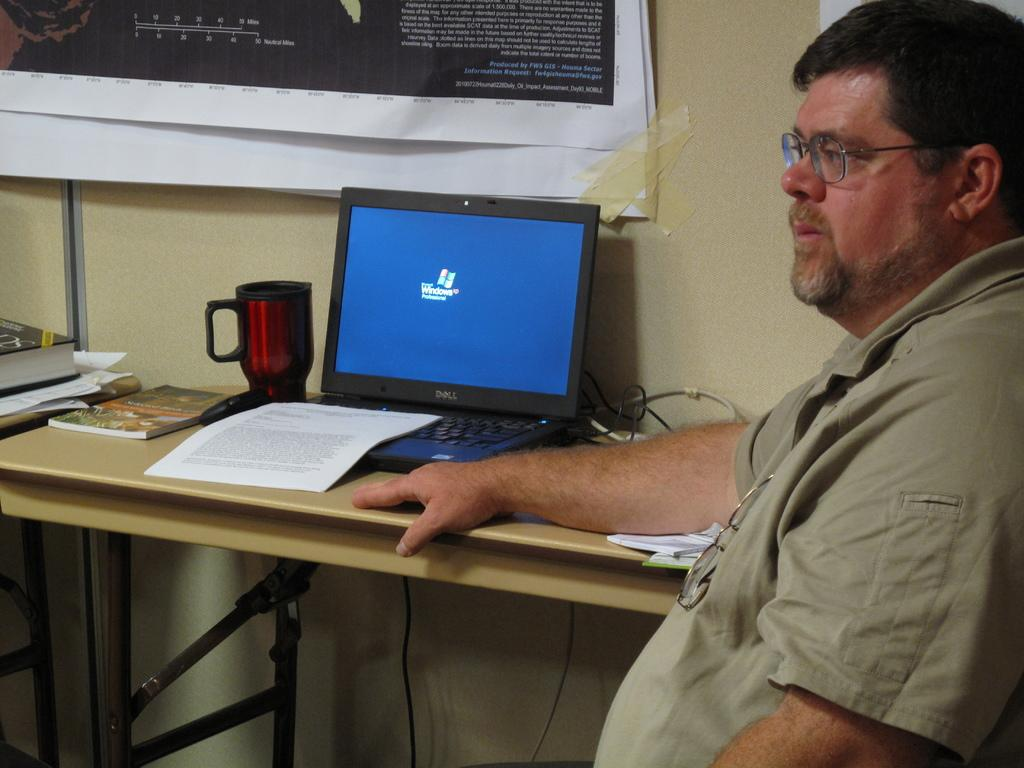What is the man in the image doing? The man is sitting in the image. What is located beside the man? There is a table beside the man. What items can be seen on the table? There is a paper, a cup, a laptop, and books on the table. What is visible on the wall in the background? There are posters on the wall in the background. What type of swing can be seen in the middle of the image? There is no swing present in the image; it features a man sitting at a table with various items. Is the man using a quill to write on the paper in the image? There is no quill visible in the image, and the man is not shown writing on the paper. 